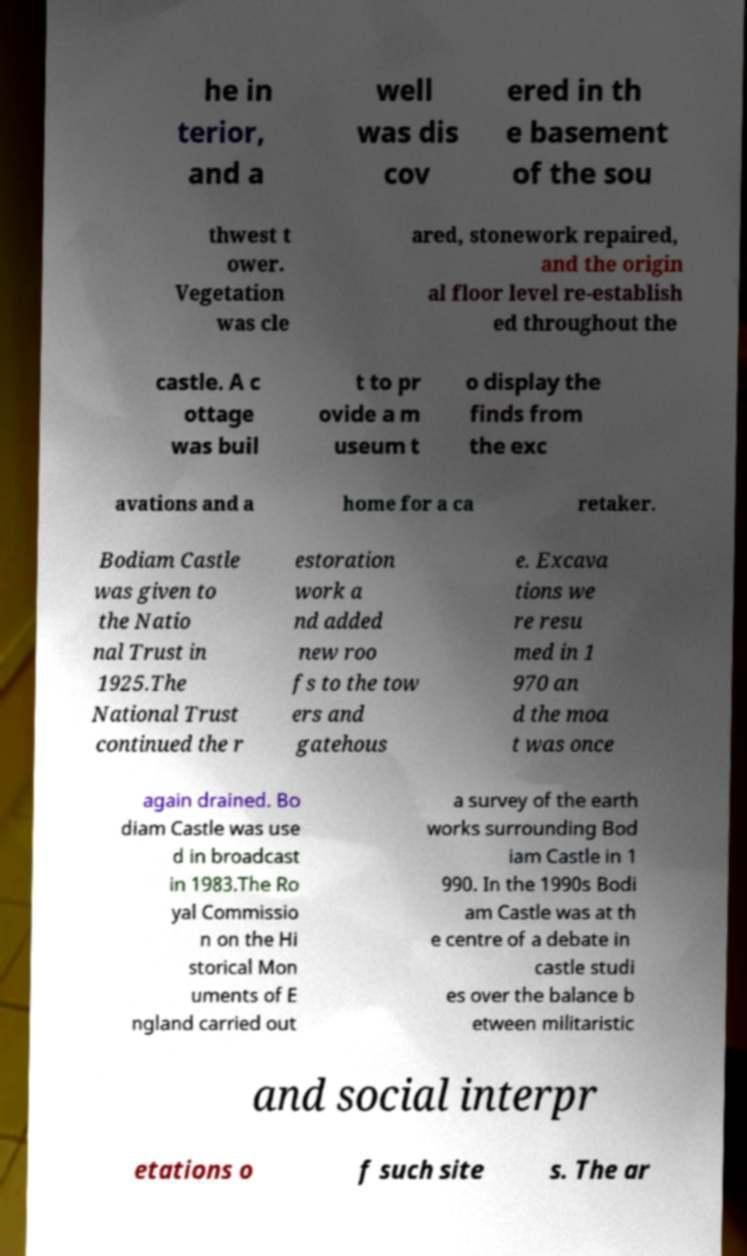For documentation purposes, I need the text within this image transcribed. Could you provide that? he in terior, and a well was dis cov ered in th e basement of the sou thwest t ower. Vegetation was cle ared, stonework repaired, and the origin al floor level re-establish ed throughout the castle. A c ottage was buil t to pr ovide a m useum t o display the finds from the exc avations and a home for a ca retaker. Bodiam Castle was given to the Natio nal Trust in 1925.The National Trust continued the r estoration work a nd added new roo fs to the tow ers and gatehous e. Excava tions we re resu med in 1 970 an d the moa t was once again drained. Bo diam Castle was use d in broadcast in 1983.The Ro yal Commissio n on the Hi storical Mon uments of E ngland carried out a survey of the earth works surrounding Bod iam Castle in 1 990. In the 1990s Bodi am Castle was at th e centre of a debate in castle studi es over the balance b etween militaristic and social interpr etations o f such site s. The ar 